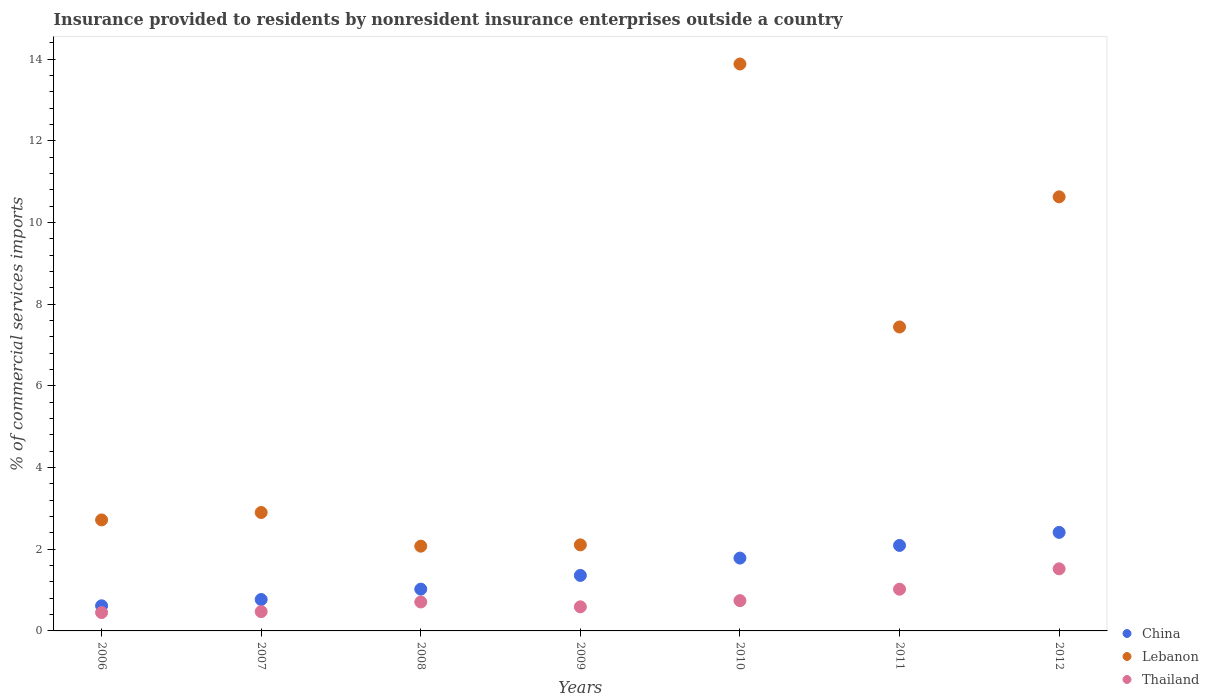How many different coloured dotlines are there?
Offer a very short reply. 3. Is the number of dotlines equal to the number of legend labels?
Keep it short and to the point. Yes. What is the Insurance provided to residents in Thailand in 2009?
Give a very brief answer. 0.59. Across all years, what is the maximum Insurance provided to residents in Thailand?
Your answer should be very brief. 1.52. Across all years, what is the minimum Insurance provided to residents in China?
Ensure brevity in your answer.  0.62. In which year was the Insurance provided to residents in Lebanon maximum?
Provide a short and direct response. 2010. What is the total Insurance provided to residents in Lebanon in the graph?
Offer a very short reply. 41.75. What is the difference between the Insurance provided to residents in Thailand in 2007 and that in 2011?
Keep it short and to the point. -0.55. What is the difference between the Insurance provided to residents in Thailand in 2009 and the Insurance provided to residents in Lebanon in 2010?
Your answer should be compact. -13.29. What is the average Insurance provided to residents in China per year?
Give a very brief answer. 1.44. In the year 2010, what is the difference between the Insurance provided to residents in Lebanon and Insurance provided to residents in Thailand?
Provide a succinct answer. 13.14. In how many years, is the Insurance provided to residents in Lebanon greater than 10 %?
Make the answer very short. 2. What is the ratio of the Insurance provided to residents in Thailand in 2008 to that in 2009?
Provide a succinct answer. 1.2. Is the Insurance provided to residents in Thailand in 2008 less than that in 2012?
Your answer should be very brief. Yes. What is the difference between the highest and the second highest Insurance provided to residents in Lebanon?
Make the answer very short. 3.25. What is the difference between the highest and the lowest Insurance provided to residents in Thailand?
Provide a succinct answer. 1.07. Is it the case that in every year, the sum of the Insurance provided to residents in Thailand and Insurance provided to residents in China  is greater than the Insurance provided to residents in Lebanon?
Offer a terse response. No. How many dotlines are there?
Provide a succinct answer. 3. Are the values on the major ticks of Y-axis written in scientific E-notation?
Keep it short and to the point. No. Does the graph contain any zero values?
Your answer should be compact. No. How many legend labels are there?
Provide a succinct answer. 3. What is the title of the graph?
Give a very brief answer. Insurance provided to residents by nonresident insurance enterprises outside a country. Does "Equatorial Guinea" appear as one of the legend labels in the graph?
Make the answer very short. No. What is the label or title of the X-axis?
Your answer should be very brief. Years. What is the label or title of the Y-axis?
Offer a very short reply. % of commercial services imports. What is the % of commercial services imports of China in 2006?
Provide a succinct answer. 0.62. What is the % of commercial services imports of Lebanon in 2006?
Give a very brief answer. 2.72. What is the % of commercial services imports of Thailand in 2006?
Give a very brief answer. 0.45. What is the % of commercial services imports in China in 2007?
Your answer should be compact. 0.77. What is the % of commercial services imports in Lebanon in 2007?
Give a very brief answer. 2.9. What is the % of commercial services imports in Thailand in 2007?
Make the answer very short. 0.47. What is the % of commercial services imports of China in 2008?
Offer a terse response. 1.02. What is the % of commercial services imports of Lebanon in 2008?
Keep it short and to the point. 2.07. What is the % of commercial services imports in Thailand in 2008?
Provide a succinct answer. 0.71. What is the % of commercial services imports in China in 2009?
Make the answer very short. 1.36. What is the % of commercial services imports of Lebanon in 2009?
Offer a terse response. 2.11. What is the % of commercial services imports of Thailand in 2009?
Your answer should be compact. 0.59. What is the % of commercial services imports of China in 2010?
Provide a succinct answer. 1.78. What is the % of commercial services imports in Lebanon in 2010?
Give a very brief answer. 13.88. What is the % of commercial services imports in Thailand in 2010?
Offer a very short reply. 0.74. What is the % of commercial services imports in China in 2011?
Offer a very short reply. 2.09. What is the % of commercial services imports in Lebanon in 2011?
Offer a very short reply. 7.44. What is the % of commercial services imports in Thailand in 2011?
Provide a succinct answer. 1.02. What is the % of commercial services imports of China in 2012?
Provide a succinct answer. 2.41. What is the % of commercial services imports of Lebanon in 2012?
Provide a short and direct response. 10.63. What is the % of commercial services imports of Thailand in 2012?
Your answer should be compact. 1.52. Across all years, what is the maximum % of commercial services imports of China?
Your answer should be very brief. 2.41. Across all years, what is the maximum % of commercial services imports in Lebanon?
Keep it short and to the point. 13.88. Across all years, what is the maximum % of commercial services imports in Thailand?
Give a very brief answer. 1.52. Across all years, what is the minimum % of commercial services imports of China?
Your answer should be very brief. 0.62. Across all years, what is the minimum % of commercial services imports of Lebanon?
Ensure brevity in your answer.  2.07. Across all years, what is the minimum % of commercial services imports in Thailand?
Your response must be concise. 0.45. What is the total % of commercial services imports in China in the graph?
Give a very brief answer. 10.05. What is the total % of commercial services imports in Lebanon in the graph?
Your response must be concise. 41.75. What is the total % of commercial services imports in Thailand in the graph?
Your answer should be very brief. 5.5. What is the difference between the % of commercial services imports in China in 2006 and that in 2007?
Offer a very short reply. -0.15. What is the difference between the % of commercial services imports of Lebanon in 2006 and that in 2007?
Ensure brevity in your answer.  -0.18. What is the difference between the % of commercial services imports of Thailand in 2006 and that in 2007?
Offer a terse response. -0.02. What is the difference between the % of commercial services imports of China in 2006 and that in 2008?
Your answer should be compact. -0.41. What is the difference between the % of commercial services imports in Lebanon in 2006 and that in 2008?
Make the answer very short. 0.64. What is the difference between the % of commercial services imports of Thailand in 2006 and that in 2008?
Your response must be concise. -0.26. What is the difference between the % of commercial services imports of China in 2006 and that in 2009?
Give a very brief answer. -0.74. What is the difference between the % of commercial services imports in Lebanon in 2006 and that in 2009?
Provide a succinct answer. 0.61. What is the difference between the % of commercial services imports of Thailand in 2006 and that in 2009?
Provide a short and direct response. -0.14. What is the difference between the % of commercial services imports in China in 2006 and that in 2010?
Offer a terse response. -1.17. What is the difference between the % of commercial services imports of Lebanon in 2006 and that in 2010?
Provide a short and direct response. -11.16. What is the difference between the % of commercial services imports of Thailand in 2006 and that in 2010?
Provide a succinct answer. -0.29. What is the difference between the % of commercial services imports of China in 2006 and that in 2011?
Your answer should be compact. -1.48. What is the difference between the % of commercial services imports in Lebanon in 2006 and that in 2011?
Your answer should be compact. -4.72. What is the difference between the % of commercial services imports of Thailand in 2006 and that in 2011?
Your answer should be very brief. -0.57. What is the difference between the % of commercial services imports of China in 2006 and that in 2012?
Your answer should be compact. -1.8. What is the difference between the % of commercial services imports of Lebanon in 2006 and that in 2012?
Provide a succinct answer. -7.91. What is the difference between the % of commercial services imports in Thailand in 2006 and that in 2012?
Provide a succinct answer. -1.07. What is the difference between the % of commercial services imports of China in 2007 and that in 2008?
Give a very brief answer. -0.25. What is the difference between the % of commercial services imports of Lebanon in 2007 and that in 2008?
Provide a succinct answer. 0.82. What is the difference between the % of commercial services imports of Thailand in 2007 and that in 2008?
Ensure brevity in your answer.  -0.24. What is the difference between the % of commercial services imports in China in 2007 and that in 2009?
Provide a succinct answer. -0.59. What is the difference between the % of commercial services imports in Lebanon in 2007 and that in 2009?
Keep it short and to the point. 0.79. What is the difference between the % of commercial services imports of Thailand in 2007 and that in 2009?
Offer a terse response. -0.12. What is the difference between the % of commercial services imports in China in 2007 and that in 2010?
Ensure brevity in your answer.  -1.01. What is the difference between the % of commercial services imports in Lebanon in 2007 and that in 2010?
Your answer should be very brief. -10.98. What is the difference between the % of commercial services imports in Thailand in 2007 and that in 2010?
Offer a very short reply. -0.27. What is the difference between the % of commercial services imports of China in 2007 and that in 2011?
Give a very brief answer. -1.32. What is the difference between the % of commercial services imports of Lebanon in 2007 and that in 2011?
Keep it short and to the point. -4.54. What is the difference between the % of commercial services imports in Thailand in 2007 and that in 2011?
Make the answer very short. -0.55. What is the difference between the % of commercial services imports of China in 2007 and that in 2012?
Keep it short and to the point. -1.64. What is the difference between the % of commercial services imports in Lebanon in 2007 and that in 2012?
Keep it short and to the point. -7.73. What is the difference between the % of commercial services imports of Thailand in 2007 and that in 2012?
Keep it short and to the point. -1.05. What is the difference between the % of commercial services imports of China in 2008 and that in 2009?
Give a very brief answer. -0.34. What is the difference between the % of commercial services imports in Lebanon in 2008 and that in 2009?
Give a very brief answer. -0.03. What is the difference between the % of commercial services imports in Thailand in 2008 and that in 2009?
Your response must be concise. 0.12. What is the difference between the % of commercial services imports in China in 2008 and that in 2010?
Give a very brief answer. -0.76. What is the difference between the % of commercial services imports of Lebanon in 2008 and that in 2010?
Make the answer very short. -11.81. What is the difference between the % of commercial services imports in Thailand in 2008 and that in 2010?
Provide a short and direct response. -0.03. What is the difference between the % of commercial services imports in China in 2008 and that in 2011?
Your answer should be compact. -1.07. What is the difference between the % of commercial services imports of Lebanon in 2008 and that in 2011?
Offer a terse response. -5.37. What is the difference between the % of commercial services imports of Thailand in 2008 and that in 2011?
Keep it short and to the point. -0.31. What is the difference between the % of commercial services imports in China in 2008 and that in 2012?
Keep it short and to the point. -1.39. What is the difference between the % of commercial services imports in Lebanon in 2008 and that in 2012?
Offer a very short reply. -8.55. What is the difference between the % of commercial services imports in Thailand in 2008 and that in 2012?
Give a very brief answer. -0.81. What is the difference between the % of commercial services imports of China in 2009 and that in 2010?
Provide a short and direct response. -0.42. What is the difference between the % of commercial services imports of Lebanon in 2009 and that in 2010?
Your answer should be compact. -11.77. What is the difference between the % of commercial services imports of Thailand in 2009 and that in 2010?
Offer a terse response. -0.15. What is the difference between the % of commercial services imports in China in 2009 and that in 2011?
Keep it short and to the point. -0.73. What is the difference between the % of commercial services imports in Lebanon in 2009 and that in 2011?
Provide a short and direct response. -5.33. What is the difference between the % of commercial services imports in Thailand in 2009 and that in 2011?
Your response must be concise. -0.43. What is the difference between the % of commercial services imports in China in 2009 and that in 2012?
Your answer should be compact. -1.05. What is the difference between the % of commercial services imports of Lebanon in 2009 and that in 2012?
Provide a short and direct response. -8.52. What is the difference between the % of commercial services imports of Thailand in 2009 and that in 2012?
Your response must be concise. -0.93. What is the difference between the % of commercial services imports in China in 2010 and that in 2011?
Provide a short and direct response. -0.31. What is the difference between the % of commercial services imports in Lebanon in 2010 and that in 2011?
Your response must be concise. 6.44. What is the difference between the % of commercial services imports in Thailand in 2010 and that in 2011?
Offer a very short reply. -0.28. What is the difference between the % of commercial services imports of China in 2010 and that in 2012?
Your answer should be compact. -0.63. What is the difference between the % of commercial services imports in Lebanon in 2010 and that in 2012?
Keep it short and to the point. 3.25. What is the difference between the % of commercial services imports of Thailand in 2010 and that in 2012?
Your answer should be very brief. -0.78. What is the difference between the % of commercial services imports in China in 2011 and that in 2012?
Your answer should be very brief. -0.32. What is the difference between the % of commercial services imports of Lebanon in 2011 and that in 2012?
Your answer should be very brief. -3.19. What is the difference between the % of commercial services imports in Thailand in 2011 and that in 2012?
Give a very brief answer. -0.5. What is the difference between the % of commercial services imports in China in 2006 and the % of commercial services imports in Lebanon in 2007?
Provide a short and direct response. -2.28. What is the difference between the % of commercial services imports of China in 2006 and the % of commercial services imports of Thailand in 2007?
Your response must be concise. 0.14. What is the difference between the % of commercial services imports of Lebanon in 2006 and the % of commercial services imports of Thailand in 2007?
Offer a very short reply. 2.24. What is the difference between the % of commercial services imports in China in 2006 and the % of commercial services imports in Lebanon in 2008?
Provide a short and direct response. -1.46. What is the difference between the % of commercial services imports in China in 2006 and the % of commercial services imports in Thailand in 2008?
Your answer should be very brief. -0.09. What is the difference between the % of commercial services imports in Lebanon in 2006 and the % of commercial services imports in Thailand in 2008?
Provide a short and direct response. 2.01. What is the difference between the % of commercial services imports of China in 2006 and the % of commercial services imports of Lebanon in 2009?
Make the answer very short. -1.49. What is the difference between the % of commercial services imports of China in 2006 and the % of commercial services imports of Thailand in 2009?
Provide a succinct answer. 0.03. What is the difference between the % of commercial services imports of Lebanon in 2006 and the % of commercial services imports of Thailand in 2009?
Provide a succinct answer. 2.13. What is the difference between the % of commercial services imports in China in 2006 and the % of commercial services imports in Lebanon in 2010?
Your answer should be very brief. -13.27. What is the difference between the % of commercial services imports in China in 2006 and the % of commercial services imports in Thailand in 2010?
Provide a short and direct response. -0.13. What is the difference between the % of commercial services imports of Lebanon in 2006 and the % of commercial services imports of Thailand in 2010?
Offer a terse response. 1.98. What is the difference between the % of commercial services imports of China in 2006 and the % of commercial services imports of Lebanon in 2011?
Give a very brief answer. -6.83. What is the difference between the % of commercial services imports of China in 2006 and the % of commercial services imports of Thailand in 2011?
Offer a terse response. -0.41. What is the difference between the % of commercial services imports of Lebanon in 2006 and the % of commercial services imports of Thailand in 2011?
Offer a terse response. 1.7. What is the difference between the % of commercial services imports of China in 2006 and the % of commercial services imports of Lebanon in 2012?
Your response must be concise. -10.01. What is the difference between the % of commercial services imports in China in 2006 and the % of commercial services imports in Thailand in 2012?
Your answer should be very brief. -0.91. What is the difference between the % of commercial services imports of Lebanon in 2006 and the % of commercial services imports of Thailand in 2012?
Keep it short and to the point. 1.2. What is the difference between the % of commercial services imports of China in 2007 and the % of commercial services imports of Lebanon in 2008?
Your response must be concise. -1.31. What is the difference between the % of commercial services imports of China in 2007 and the % of commercial services imports of Thailand in 2008?
Offer a terse response. 0.06. What is the difference between the % of commercial services imports in Lebanon in 2007 and the % of commercial services imports in Thailand in 2008?
Your response must be concise. 2.19. What is the difference between the % of commercial services imports in China in 2007 and the % of commercial services imports in Lebanon in 2009?
Your response must be concise. -1.34. What is the difference between the % of commercial services imports in China in 2007 and the % of commercial services imports in Thailand in 2009?
Keep it short and to the point. 0.18. What is the difference between the % of commercial services imports of Lebanon in 2007 and the % of commercial services imports of Thailand in 2009?
Your answer should be very brief. 2.31. What is the difference between the % of commercial services imports of China in 2007 and the % of commercial services imports of Lebanon in 2010?
Provide a short and direct response. -13.11. What is the difference between the % of commercial services imports of China in 2007 and the % of commercial services imports of Thailand in 2010?
Make the answer very short. 0.03. What is the difference between the % of commercial services imports of Lebanon in 2007 and the % of commercial services imports of Thailand in 2010?
Offer a very short reply. 2.16. What is the difference between the % of commercial services imports in China in 2007 and the % of commercial services imports in Lebanon in 2011?
Your response must be concise. -6.67. What is the difference between the % of commercial services imports of China in 2007 and the % of commercial services imports of Thailand in 2011?
Offer a very short reply. -0.25. What is the difference between the % of commercial services imports of Lebanon in 2007 and the % of commercial services imports of Thailand in 2011?
Give a very brief answer. 1.88. What is the difference between the % of commercial services imports of China in 2007 and the % of commercial services imports of Lebanon in 2012?
Your answer should be compact. -9.86. What is the difference between the % of commercial services imports of China in 2007 and the % of commercial services imports of Thailand in 2012?
Your response must be concise. -0.75. What is the difference between the % of commercial services imports of Lebanon in 2007 and the % of commercial services imports of Thailand in 2012?
Ensure brevity in your answer.  1.38. What is the difference between the % of commercial services imports in China in 2008 and the % of commercial services imports in Lebanon in 2009?
Provide a succinct answer. -1.08. What is the difference between the % of commercial services imports of China in 2008 and the % of commercial services imports of Thailand in 2009?
Keep it short and to the point. 0.43. What is the difference between the % of commercial services imports of Lebanon in 2008 and the % of commercial services imports of Thailand in 2009?
Ensure brevity in your answer.  1.49. What is the difference between the % of commercial services imports in China in 2008 and the % of commercial services imports in Lebanon in 2010?
Offer a terse response. -12.86. What is the difference between the % of commercial services imports in China in 2008 and the % of commercial services imports in Thailand in 2010?
Your answer should be compact. 0.28. What is the difference between the % of commercial services imports of Lebanon in 2008 and the % of commercial services imports of Thailand in 2010?
Offer a very short reply. 1.33. What is the difference between the % of commercial services imports in China in 2008 and the % of commercial services imports in Lebanon in 2011?
Provide a succinct answer. -6.42. What is the difference between the % of commercial services imports of China in 2008 and the % of commercial services imports of Thailand in 2011?
Keep it short and to the point. 0. What is the difference between the % of commercial services imports of Lebanon in 2008 and the % of commercial services imports of Thailand in 2011?
Make the answer very short. 1.05. What is the difference between the % of commercial services imports of China in 2008 and the % of commercial services imports of Lebanon in 2012?
Keep it short and to the point. -9.61. What is the difference between the % of commercial services imports of China in 2008 and the % of commercial services imports of Thailand in 2012?
Your answer should be compact. -0.5. What is the difference between the % of commercial services imports of Lebanon in 2008 and the % of commercial services imports of Thailand in 2012?
Your response must be concise. 0.55. What is the difference between the % of commercial services imports in China in 2009 and the % of commercial services imports in Lebanon in 2010?
Offer a terse response. -12.52. What is the difference between the % of commercial services imports of China in 2009 and the % of commercial services imports of Thailand in 2010?
Your answer should be very brief. 0.62. What is the difference between the % of commercial services imports in Lebanon in 2009 and the % of commercial services imports in Thailand in 2010?
Provide a succinct answer. 1.37. What is the difference between the % of commercial services imports in China in 2009 and the % of commercial services imports in Lebanon in 2011?
Offer a terse response. -6.08. What is the difference between the % of commercial services imports in China in 2009 and the % of commercial services imports in Thailand in 2011?
Provide a short and direct response. 0.34. What is the difference between the % of commercial services imports of Lebanon in 2009 and the % of commercial services imports of Thailand in 2011?
Your response must be concise. 1.09. What is the difference between the % of commercial services imports of China in 2009 and the % of commercial services imports of Lebanon in 2012?
Your answer should be very brief. -9.27. What is the difference between the % of commercial services imports of China in 2009 and the % of commercial services imports of Thailand in 2012?
Provide a short and direct response. -0.16. What is the difference between the % of commercial services imports of Lebanon in 2009 and the % of commercial services imports of Thailand in 2012?
Provide a short and direct response. 0.59. What is the difference between the % of commercial services imports of China in 2010 and the % of commercial services imports of Lebanon in 2011?
Your answer should be very brief. -5.66. What is the difference between the % of commercial services imports in China in 2010 and the % of commercial services imports in Thailand in 2011?
Your answer should be very brief. 0.76. What is the difference between the % of commercial services imports of Lebanon in 2010 and the % of commercial services imports of Thailand in 2011?
Offer a very short reply. 12.86. What is the difference between the % of commercial services imports of China in 2010 and the % of commercial services imports of Lebanon in 2012?
Provide a succinct answer. -8.84. What is the difference between the % of commercial services imports of China in 2010 and the % of commercial services imports of Thailand in 2012?
Offer a very short reply. 0.26. What is the difference between the % of commercial services imports in Lebanon in 2010 and the % of commercial services imports in Thailand in 2012?
Provide a short and direct response. 12.36. What is the difference between the % of commercial services imports in China in 2011 and the % of commercial services imports in Lebanon in 2012?
Your answer should be compact. -8.53. What is the difference between the % of commercial services imports of China in 2011 and the % of commercial services imports of Thailand in 2012?
Ensure brevity in your answer.  0.57. What is the difference between the % of commercial services imports in Lebanon in 2011 and the % of commercial services imports in Thailand in 2012?
Keep it short and to the point. 5.92. What is the average % of commercial services imports in China per year?
Your response must be concise. 1.44. What is the average % of commercial services imports in Lebanon per year?
Keep it short and to the point. 5.96. What is the average % of commercial services imports in Thailand per year?
Offer a very short reply. 0.79. In the year 2006, what is the difference between the % of commercial services imports of China and % of commercial services imports of Lebanon?
Provide a short and direct response. -2.1. In the year 2006, what is the difference between the % of commercial services imports in China and % of commercial services imports in Thailand?
Make the answer very short. 0.17. In the year 2006, what is the difference between the % of commercial services imports of Lebanon and % of commercial services imports of Thailand?
Your answer should be very brief. 2.27. In the year 2007, what is the difference between the % of commercial services imports in China and % of commercial services imports in Lebanon?
Keep it short and to the point. -2.13. In the year 2007, what is the difference between the % of commercial services imports of China and % of commercial services imports of Thailand?
Keep it short and to the point. 0.3. In the year 2007, what is the difference between the % of commercial services imports of Lebanon and % of commercial services imports of Thailand?
Keep it short and to the point. 2.43. In the year 2008, what is the difference between the % of commercial services imports in China and % of commercial services imports in Lebanon?
Offer a very short reply. -1.05. In the year 2008, what is the difference between the % of commercial services imports in China and % of commercial services imports in Thailand?
Keep it short and to the point. 0.31. In the year 2008, what is the difference between the % of commercial services imports in Lebanon and % of commercial services imports in Thailand?
Offer a terse response. 1.37. In the year 2009, what is the difference between the % of commercial services imports of China and % of commercial services imports of Lebanon?
Your response must be concise. -0.75. In the year 2009, what is the difference between the % of commercial services imports in China and % of commercial services imports in Thailand?
Keep it short and to the point. 0.77. In the year 2009, what is the difference between the % of commercial services imports in Lebanon and % of commercial services imports in Thailand?
Keep it short and to the point. 1.52. In the year 2010, what is the difference between the % of commercial services imports of China and % of commercial services imports of Lebanon?
Make the answer very short. -12.1. In the year 2010, what is the difference between the % of commercial services imports of China and % of commercial services imports of Thailand?
Make the answer very short. 1.04. In the year 2010, what is the difference between the % of commercial services imports of Lebanon and % of commercial services imports of Thailand?
Offer a very short reply. 13.14. In the year 2011, what is the difference between the % of commercial services imports of China and % of commercial services imports of Lebanon?
Offer a very short reply. -5.35. In the year 2011, what is the difference between the % of commercial services imports in China and % of commercial services imports in Thailand?
Provide a succinct answer. 1.07. In the year 2011, what is the difference between the % of commercial services imports in Lebanon and % of commercial services imports in Thailand?
Provide a succinct answer. 6.42. In the year 2012, what is the difference between the % of commercial services imports in China and % of commercial services imports in Lebanon?
Offer a terse response. -8.22. In the year 2012, what is the difference between the % of commercial services imports of China and % of commercial services imports of Thailand?
Your answer should be compact. 0.89. In the year 2012, what is the difference between the % of commercial services imports in Lebanon and % of commercial services imports in Thailand?
Offer a terse response. 9.11. What is the ratio of the % of commercial services imports of China in 2006 to that in 2007?
Keep it short and to the point. 0.8. What is the ratio of the % of commercial services imports in Lebanon in 2006 to that in 2007?
Provide a succinct answer. 0.94. What is the ratio of the % of commercial services imports of China in 2006 to that in 2008?
Your answer should be compact. 0.6. What is the ratio of the % of commercial services imports of Lebanon in 2006 to that in 2008?
Offer a very short reply. 1.31. What is the ratio of the % of commercial services imports of Thailand in 2006 to that in 2008?
Give a very brief answer. 0.63. What is the ratio of the % of commercial services imports of China in 2006 to that in 2009?
Your response must be concise. 0.45. What is the ratio of the % of commercial services imports in Lebanon in 2006 to that in 2009?
Your response must be concise. 1.29. What is the ratio of the % of commercial services imports of Thailand in 2006 to that in 2009?
Make the answer very short. 0.76. What is the ratio of the % of commercial services imports in China in 2006 to that in 2010?
Provide a short and direct response. 0.34. What is the ratio of the % of commercial services imports of Lebanon in 2006 to that in 2010?
Your answer should be compact. 0.2. What is the ratio of the % of commercial services imports of Thailand in 2006 to that in 2010?
Keep it short and to the point. 0.61. What is the ratio of the % of commercial services imports of China in 2006 to that in 2011?
Offer a very short reply. 0.29. What is the ratio of the % of commercial services imports of Lebanon in 2006 to that in 2011?
Provide a succinct answer. 0.37. What is the ratio of the % of commercial services imports in Thailand in 2006 to that in 2011?
Provide a short and direct response. 0.44. What is the ratio of the % of commercial services imports in China in 2006 to that in 2012?
Keep it short and to the point. 0.26. What is the ratio of the % of commercial services imports in Lebanon in 2006 to that in 2012?
Ensure brevity in your answer.  0.26. What is the ratio of the % of commercial services imports in Thailand in 2006 to that in 2012?
Give a very brief answer. 0.3. What is the ratio of the % of commercial services imports in China in 2007 to that in 2008?
Keep it short and to the point. 0.75. What is the ratio of the % of commercial services imports of Lebanon in 2007 to that in 2008?
Ensure brevity in your answer.  1.4. What is the ratio of the % of commercial services imports in Thailand in 2007 to that in 2008?
Keep it short and to the point. 0.67. What is the ratio of the % of commercial services imports of China in 2007 to that in 2009?
Ensure brevity in your answer.  0.57. What is the ratio of the % of commercial services imports in Lebanon in 2007 to that in 2009?
Offer a terse response. 1.38. What is the ratio of the % of commercial services imports of Thailand in 2007 to that in 2009?
Give a very brief answer. 0.8. What is the ratio of the % of commercial services imports of China in 2007 to that in 2010?
Make the answer very short. 0.43. What is the ratio of the % of commercial services imports of Lebanon in 2007 to that in 2010?
Provide a succinct answer. 0.21. What is the ratio of the % of commercial services imports in Thailand in 2007 to that in 2010?
Your response must be concise. 0.64. What is the ratio of the % of commercial services imports of China in 2007 to that in 2011?
Your response must be concise. 0.37. What is the ratio of the % of commercial services imports of Lebanon in 2007 to that in 2011?
Ensure brevity in your answer.  0.39. What is the ratio of the % of commercial services imports in Thailand in 2007 to that in 2011?
Provide a succinct answer. 0.46. What is the ratio of the % of commercial services imports of China in 2007 to that in 2012?
Your answer should be very brief. 0.32. What is the ratio of the % of commercial services imports in Lebanon in 2007 to that in 2012?
Your response must be concise. 0.27. What is the ratio of the % of commercial services imports in Thailand in 2007 to that in 2012?
Provide a short and direct response. 0.31. What is the ratio of the % of commercial services imports of China in 2008 to that in 2009?
Provide a short and direct response. 0.75. What is the ratio of the % of commercial services imports in Lebanon in 2008 to that in 2009?
Provide a succinct answer. 0.98. What is the ratio of the % of commercial services imports of Thailand in 2008 to that in 2009?
Offer a very short reply. 1.2. What is the ratio of the % of commercial services imports of China in 2008 to that in 2010?
Your answer should be compact. 0.57. What is the ratio of the % of commercial services imports in Lebanon in 2008 to that in 2010?
Your answer should be very brief. 0.15. What is the ratio of the % of commercial services imports of Thailand in 2008 to that in 2010?
Make the answer very short. 0.96. What is the ratio of the % of commercial services imports of China in 2008 to that in 2011?
Your answer should be very brief. 0.49. What is the ratio of the % of commercial services imports in Lebanon in 2008 to that in 2011?
Offer a terse response. 0.28. What is the ratio of the % of commercial services imports of Thailand in 2008 to that in 2011?
Give a very brief answer. 0.69. What is the ratio of the % of commercial services imports of China in 2008 to that in 2012?
Give a very brief answer. 0.42. What is the ratio of the % of commercial services imports of Lebanon in 2008 to that in 2012?
Your response must be concise. 0.2. What is the ratio of the % of commercial services imports of Thailand in 2008 to that in 2012?
Offer a terse response. 0.47. What is the ratio of the % of commercial services imports in China in 2009 to that in 2010?
Ensure brevity in your answer.  0.76. What is the ratio of the % of commercial services imports of Lebanon in 2009 to that in 2010?
Offer a terse response. 0.15. What is the ratio of the % of commercial services imports of Thailand in 2009 to that in 2010?
Your answer should be very brief. 0.8. What is the ratio of the % of commercial services imports of China in 2009 to that in 2011?
Provide a short and direct response. 0.65. What is the ratio of the % of commercial services imports of Lebanon in 2009 to that in 2011?
Your answer should be compact. 0.28. What is the ratio of the % of commercial services imports in Thailand in 2009 to that in 2011?
Ensure brevity in your answer.  0.58. What is the ratio of the % of commercial services imports in China in 2009 to that in 2012?
Provide a short and direct response. 0.56. What is the ratio of the % of commercial services imports in Lebanon in 2009 to that in 2012?
Give a very brief answer. 0.2. What is the ratio of the % of commercial services imports of Thailand in 2009 to that in 2012?
Give a very brief answer. 0.39. What is the ratio of the % of commercial services imports in China in 2010 to that in 2011?
Provide a succinct answer. 0.85. What is the ratio of the % of commercial services imports of Lebanon in 2010 to that in 2011?
Provide a short and direct response. 1.87. What is the ratio of the % of commercial services imports of Thailand in 2010 to that in 2011?
Ensure brevity in your answer.  0.73. What is the ratio of the % of commercial services imports in China in 2010 to that in 2012?
Ensure brevity in your answer.  0.74. What is the ratio of the % of commercial services imports in Lebanon in 2010 to that in 2012?
Offer a terse response. 1.31. What is the ratio of the % of commercial services imports in Thailand in 2010 to that in 2012?
Make the answer very short. 0.49. What is the ratio of the % of commercial services imports of China in 2011 to that in 2012?
Provide a succinct answer. 0.87. What is the ratio of the % of commercial services imports in Lebanon in 2011 to that in 2012?
Offer a very short reply. 0.7. What is the ratio of the % of commercial services imports of Thailand in 2011 to that in 2012?
Give a very brief answer. 0.67. What is the difference between the highest and the second highest % of commercial services imports of China?
Offer a terse response. 0.32. What is the difference between the highest and the second highest % of commercial services imports of Lebanon?
Your answer should be compact. 3.25. What is the difference between the highest and the second highest % of commercial services imports of Thailand?
Provide a short and direct response. 0.5. What is the difference between the highest and the lowest % of commercial services imports of China?
Provide a short and direct response. 1.8. What is the difference between the highest and the lowest % of commercial services imports in Lebanon?
Ensure brevity in your answer.  11.81. What is the difference between the highest and the lowest % of commercial services imports in Thailand?
Your answer should be very brief. 1.07. 